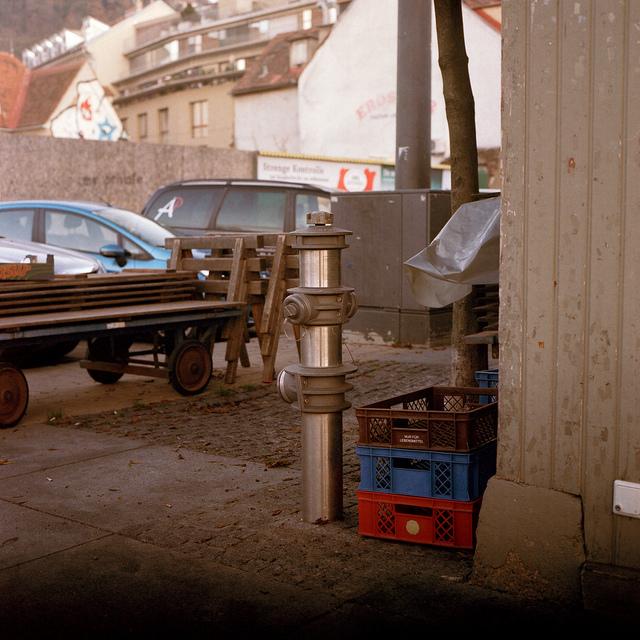What is the fire hydrant made of?
Give a very brief answer. Metal. Is this a parking lot for motorcycles?
Write a very short answer. No. How many blue cars are in the photo?
Quick response, please. 1. How many crates are in  the photo?
Keep it brief. 3. Overcast or sunny?
Write a very short answer. Overcast. How many wheels are on the cart?
Quick response, please. 4. Has this car been driven recently?
Concise answer only. Yes. What kind of containers are these?
Short answer required. Crates. 